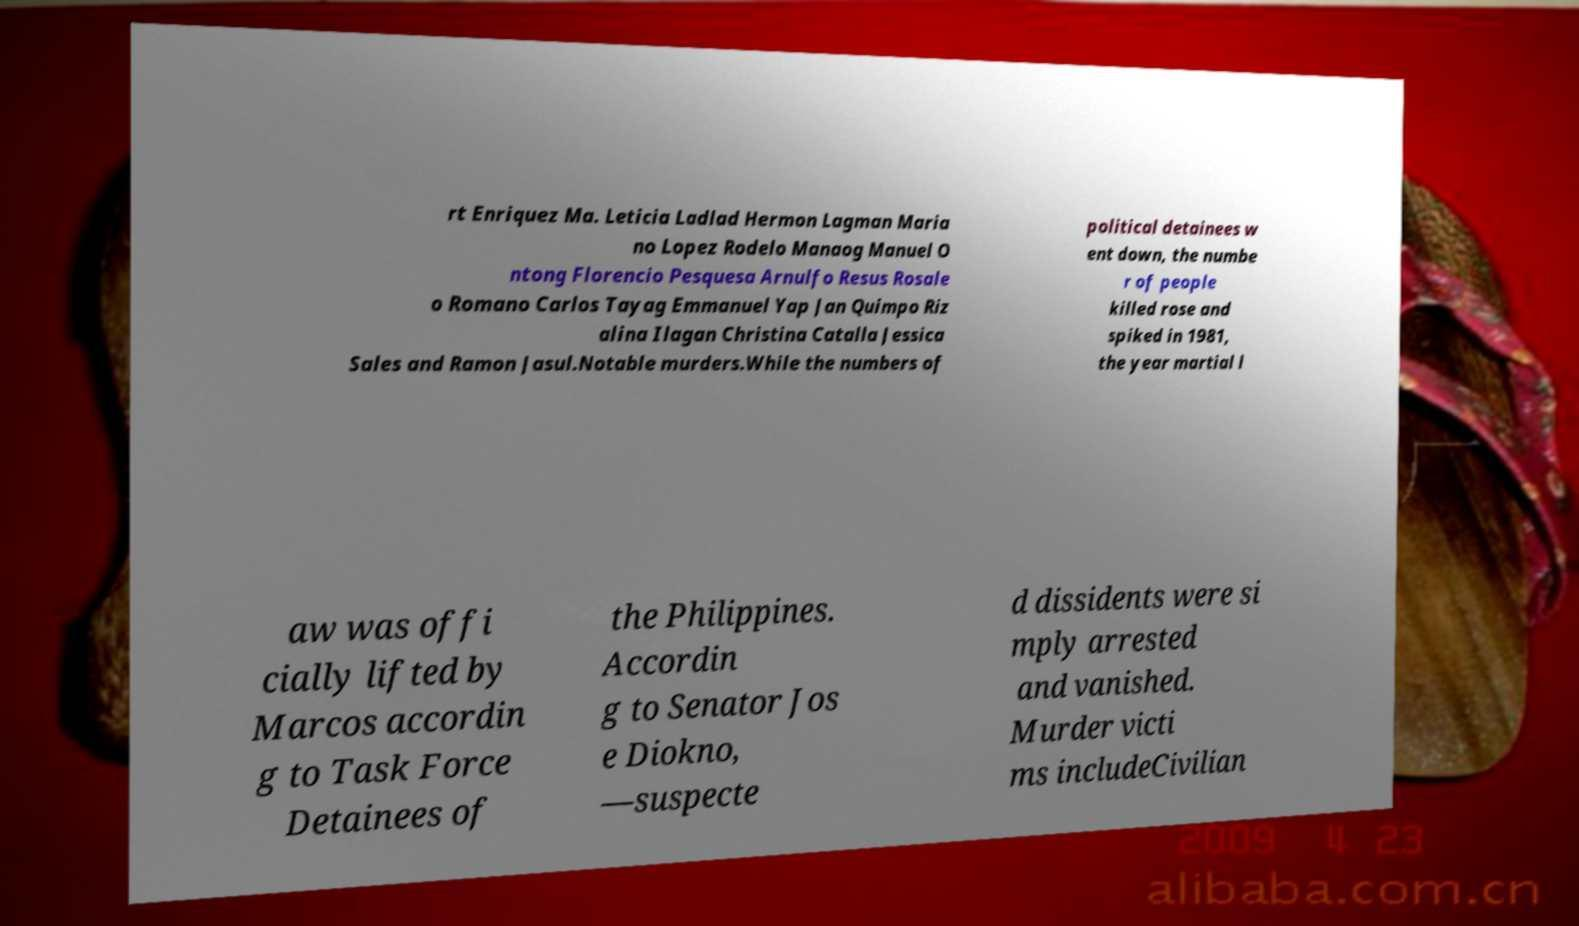I need the written content from this picture converted into text. Can you do that? rt Enriquez Ma. Leticia Ladlad Hermon Lagman Maria no Lopez Rodelo Manaog Manuel O ntong Florencio Pesquesa Arnulfo Resus Rosale o Romano Carlos Tayag Emmanuel Yap Jan Quimpo Riz alina Ilagan Christina Catalla Jessica Sales and Ramon Jasul.Notable murders.While the numbers of political detainees w ent down, the numbe r of people killed rose and spiked in 1981, the year martial l aw was offi cially lifted by Marcos accordin g to Task Force Detainees of the Philippines. Accordin g to Senator Jos e Diokno, —suspecte d dissidents were si mply arrested and vanished. Murder victi ms includeCivilian 